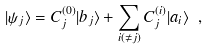Convert formula to latex. <formula><loc_0><loc_0><loc_500><loc_500>| \psi _ { j } \rangle = C _ { j } ^ { ( 0 ) } | b _ { j } \rangle + \sum _ { i ( \ne j ) } C _ { j } ^ { ( i ) } | a _ { i } \rangle \ ,</formula> 